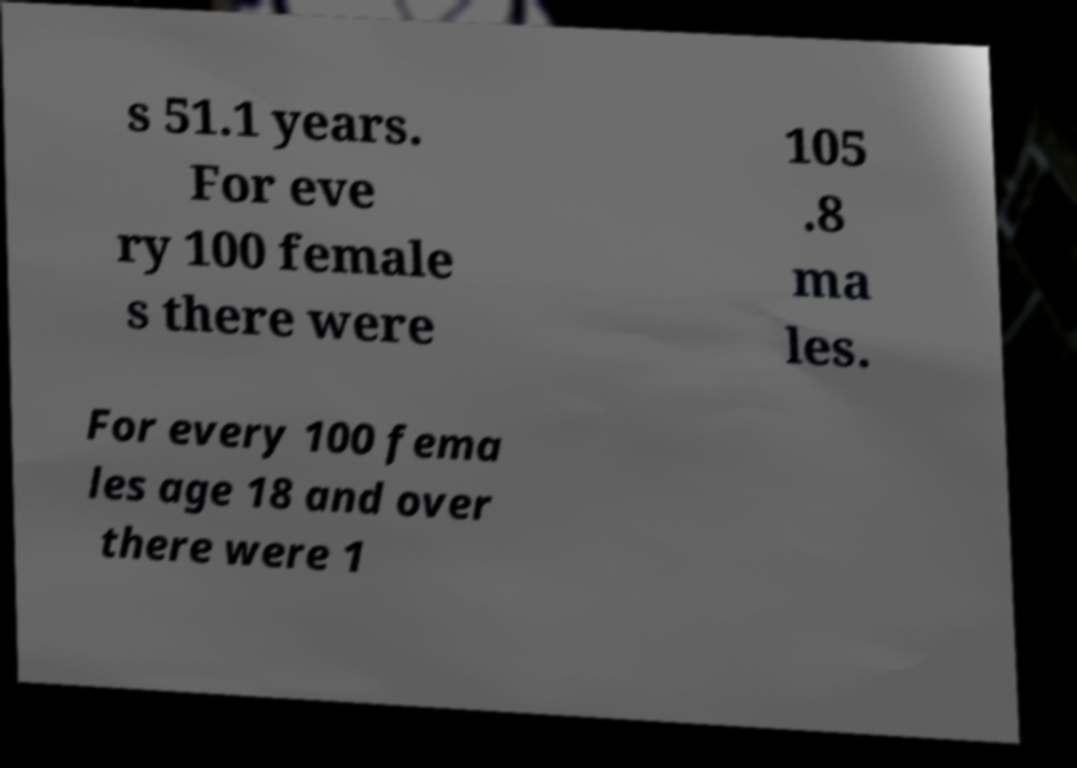Could you extract and type out the text from this image? s 51.1 years. For eve ry 100 female s there were 105 .8 ma les. For every 100 fema les age 18 and over there were 1 